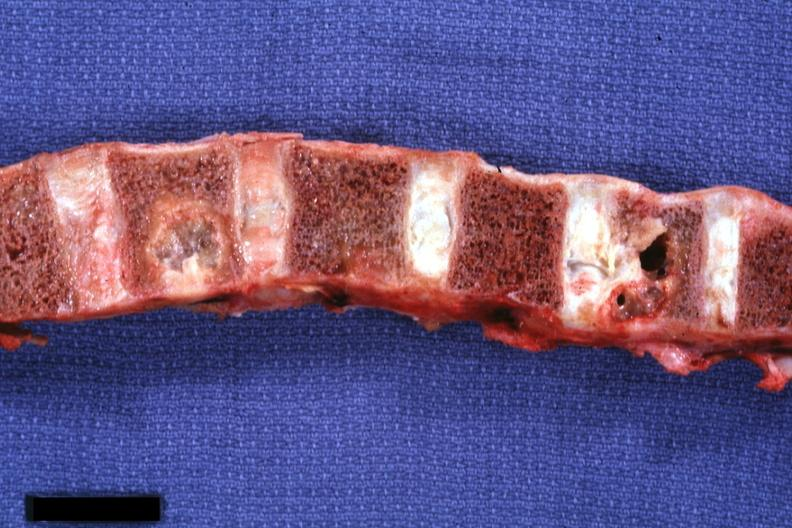what does this image show?
Answer the question using a single word or phrase. Vertebral column with well shown gross lesions 